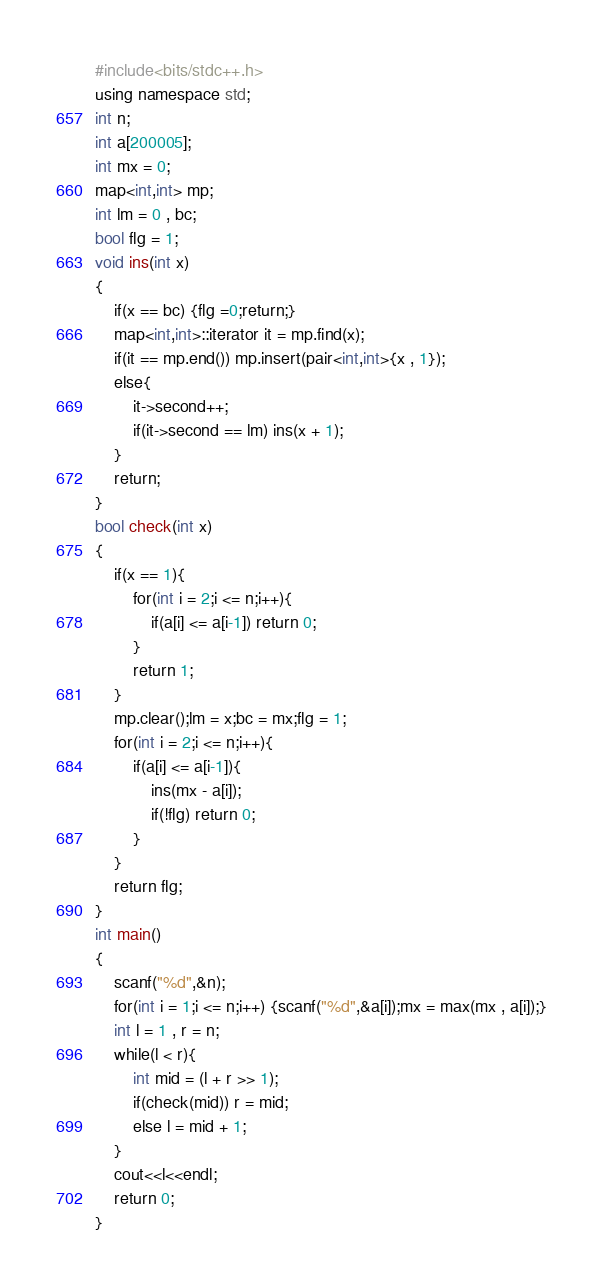Convert code to text. <code><loc_0><loc_0><loc_500><loc_500><_C++_>#include<bits/stdc++.h>
using namespace std;
int n;
int a[200005];
int mx = 0;
map<int,int> mp;
int lm = 0 , bc;
bool flg = 1;
void ins(int x)
{
    if(x == bc) {flg =0;return;}
    map<int,int>::iterator it = mp.find(x);
    if(it == mp.end()) mp.insert(pair<int,int>{x , 1});
    else{
        it->second++;
        if(it->second == lm) ins(x + 1);
    }
    return;
}
bool check(int x)
{
    if(x == 1){
        for(int i = 2;i <= n;i++){
            if(a[i] <= a[i-1]) return 0;
        }
        return 1;
    }
    mp.clear();lm = x;bc = mx;flg = 1;
    for(int i = 2;i <= n;i++){
        if(a[i] <= a[i-1]){
            ins(mx - a[i]);
            if(!flg) return 0;
        }
    }
    return flg;
}
int main()
{
    scanf("%d",&n);
    for(int i = 1;i <= n;i++) {scanf("%d",&a[i]);mx = max(mx , a[i]);}
    int l = 1 , r = n;
    while(l < r){
        int mid = (l + r >> 1);
        if(check(mid)) r = mid;
        else l = mid + 1;
    }
    cout<<l<<endl;
    return 0;
}
</code> 